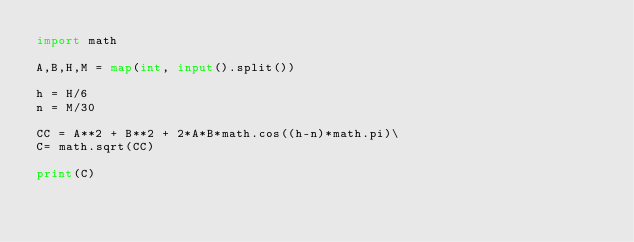<code> <loc_0><loc_0><loc_500><loc_500><_Python_>import math

A,B,H,M = map(int, input().split())

h = H/6
n = M/30

CC = A**2 + B**2 + 2*A*B*math.cos((h-n)*math.pi)\  
C= math.sqrt(CC)

print(C)</code> 